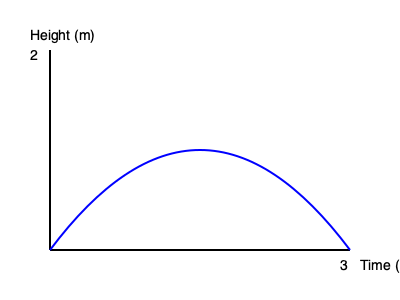The graph shows the trajectory of a 16kg kettlebell during a swing. If the swing takes 3 seconds to complete and reaches a maximum height of 2 meters, what is the average velocity of the kettlebell in m/s? To calculate the average velocity, we need to determine the total distance traveled and divide it by the total time:

1. The graph shows a parabolic path, which can be approximated as a semicircle for this problem.
2. The diameter of this semicircle is 3 seconds (time axis).
3. The circumference of a full circle is given by $C = 2\pi r$, where $r$ is the radius.
4. For a semicircle, we use half of this formula: $C_{semicircle} = \pi r$
5. The radius is half the diameter, so $r = 1.5$ seconds.
6. Calculate the length of the path: $L = \pi \cdot 1.5 = 4.71$ meters
7. Average velocity is distance divided by time: $v_{avg} = \frac{d}{t} = \frac{4.71 \text{ m}}{3 \text{ s}} = 1.57 \text{ m/s}$

Therefore, the average velocity of the kettlebell is approximately 1.57 m/s.
Answer: 1.57 m/s 